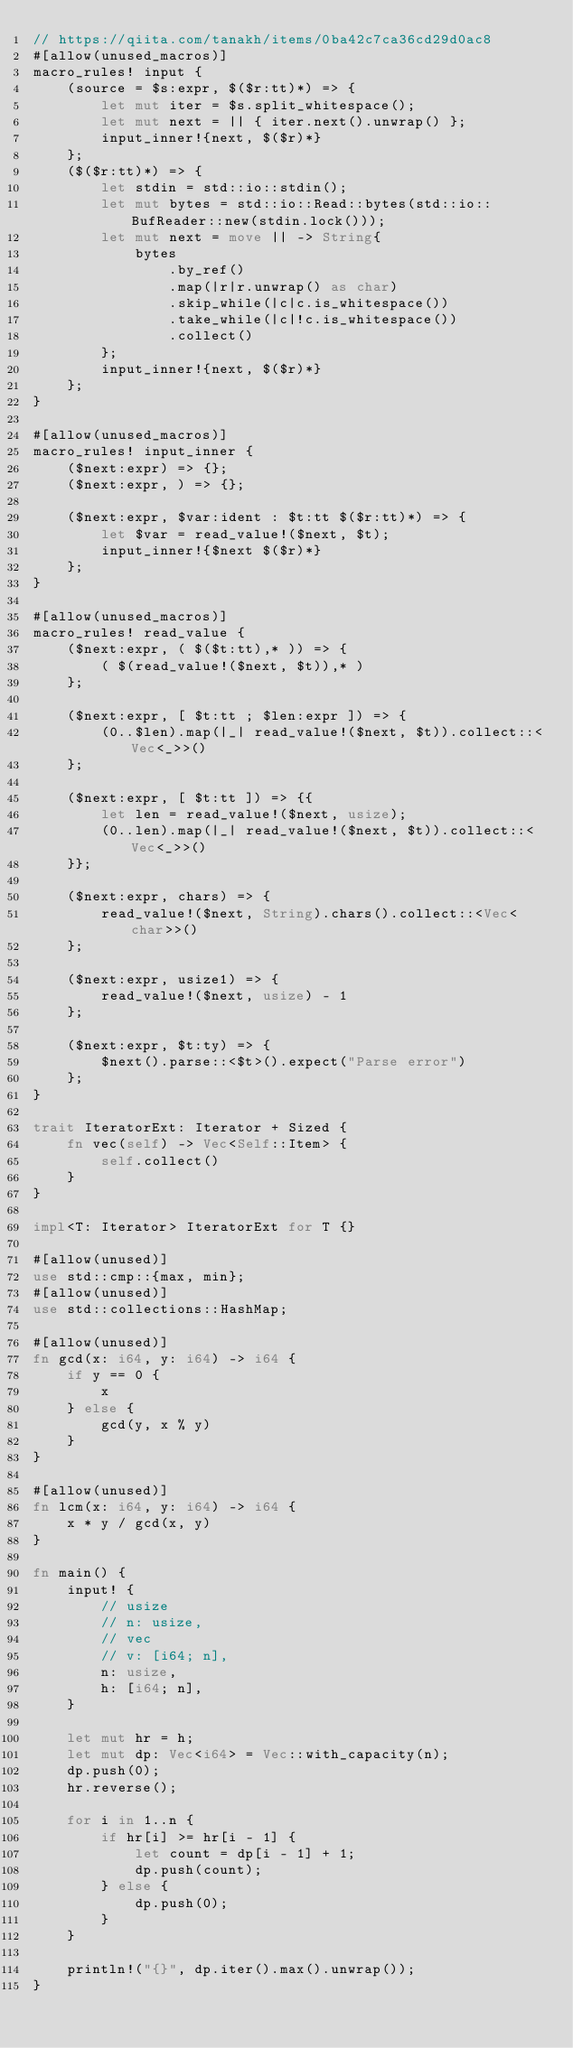Convert code to text. <code><loc_0><loc_0><loc_500><loc_500><_Rust_>// https://qiita.com/tanakh/items/0ba42c7ca36cd29d0ac8
#[allow(unused_macros)]
macro_rules! input {
    (source = $s:expr, $($r:tt)*) => {
        let mut iter = $s.split_whitespace();
        let mut next = || { iter.next().unwrap() };
        input_inner!{next, $($r)*}
    };
    ($($r:tt)*) => {
        let stdin = std::io::stdin();
        let mut bytes = std::io::Read::bytes(std::io::BufReader::new(stdin.lock()));
        let mut next = move || -> String{
            bytes
                .by_ref()
                .map(|r|r.unwrap() as char)
                .skip_while(|c|c.is_whitespace())
                .take_while(|c|!c.is_whitespace())
                .collect()
        };
        input_inner!{next, $($r)*}
    };
}

#[allow(unused_macros)]
macro_rules! input_inner {
    ($next:expr) => {};
    ($next:expr, ) => {};

    ($next:expr, $var:ident : $t:tt $($r:tt)*) => {
        let $var = read_value!($next, $t);
        input_inner!{$next $($r)*}
    };
}

#[allow(unused_macros)]
macro_rules! read_value {
    ($next:expr, ( $($t:tt),* )) => {
        ( $(read_value!($next, $t)),* )
    };

    ($next:expr, [ $t:tt ; $len:expr ]) => {
        (0..$len).map(|_| read_value!($next, $t)).collect::<Vec<_>>()
    };

    ($next:expr, [ $t:tt ]) => {{
        let len = read_value!($next, usize);
        (0..len).map(|_| read_value!($next, $t)).collect::<Vec<_>>()
    }};

    ($next:expr, chars) => {
        read_value!($next, String).chars().collect::<Vec<char>>()
    };

    ($next:expr, usize1) => {
        read_value!($next, usize) - 1
    };

    ($next:expr, $t:ty) => {
        $next().parse::<$t>().expect("Parse error")
    };
}

trait IteratorExt: Iterator + Sized {
    fn vec(self) -> Vec<Self::Item> {
        self.collect()
    }
}

impl<T: Iterator> IteratorExt for T {}

#[allow(unused)]
use std::cmp::{max, min};
#[allow(unused)]
use std::collections::HashMap;

#[allow(unused)]
fn gcd(x: i64, y: i64) -> i64 {
    if y == 0 {
        x
    } else {
        gcd(y, x % y)
    }
}

#[allow(unused)]
fn lcm(x: i64, y: i64) -> i64 {
    x * y / gcd(x, y)
}

fn main() {
    input! {
        // usize
        // n: usize,
        // vec
        // v: [i64; n],
        n: usize,
        h: [i64; n],
    }

    let mut hr = h;
    let mut dp: Vec<i64> = Vec::with_capacity(n);
    dp.push(0);
    hr.reverse();

    for i in 1..n {
        if hr[i] >= hr[i - 1] {
            let count = dp[i - 1] + 1;
            dp.push(count);
        } else {
            dp.push(0);
        }
    }

    println!("{}", dp.iter().max().unwrap());
}
</code> 